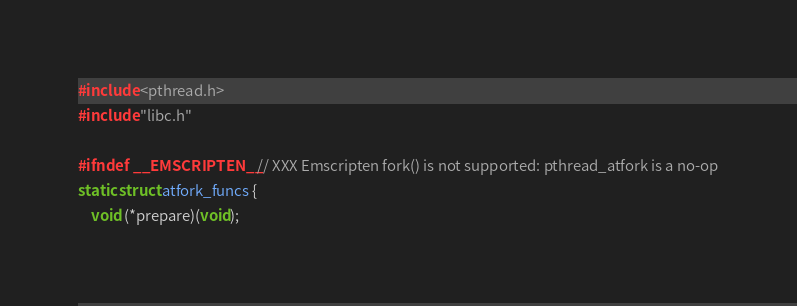<code> <loc_0><loc_0><loc_500><loc_500><_C_>#include <pthread.h>
#include "libc.h"

#ifndef __EMSCRIPTEN__ // XXX Emscripten fork() is not supported: pthread_atfork is a no-op
static struct atfork_funcs {
	void (*prepare)(void);</code> 